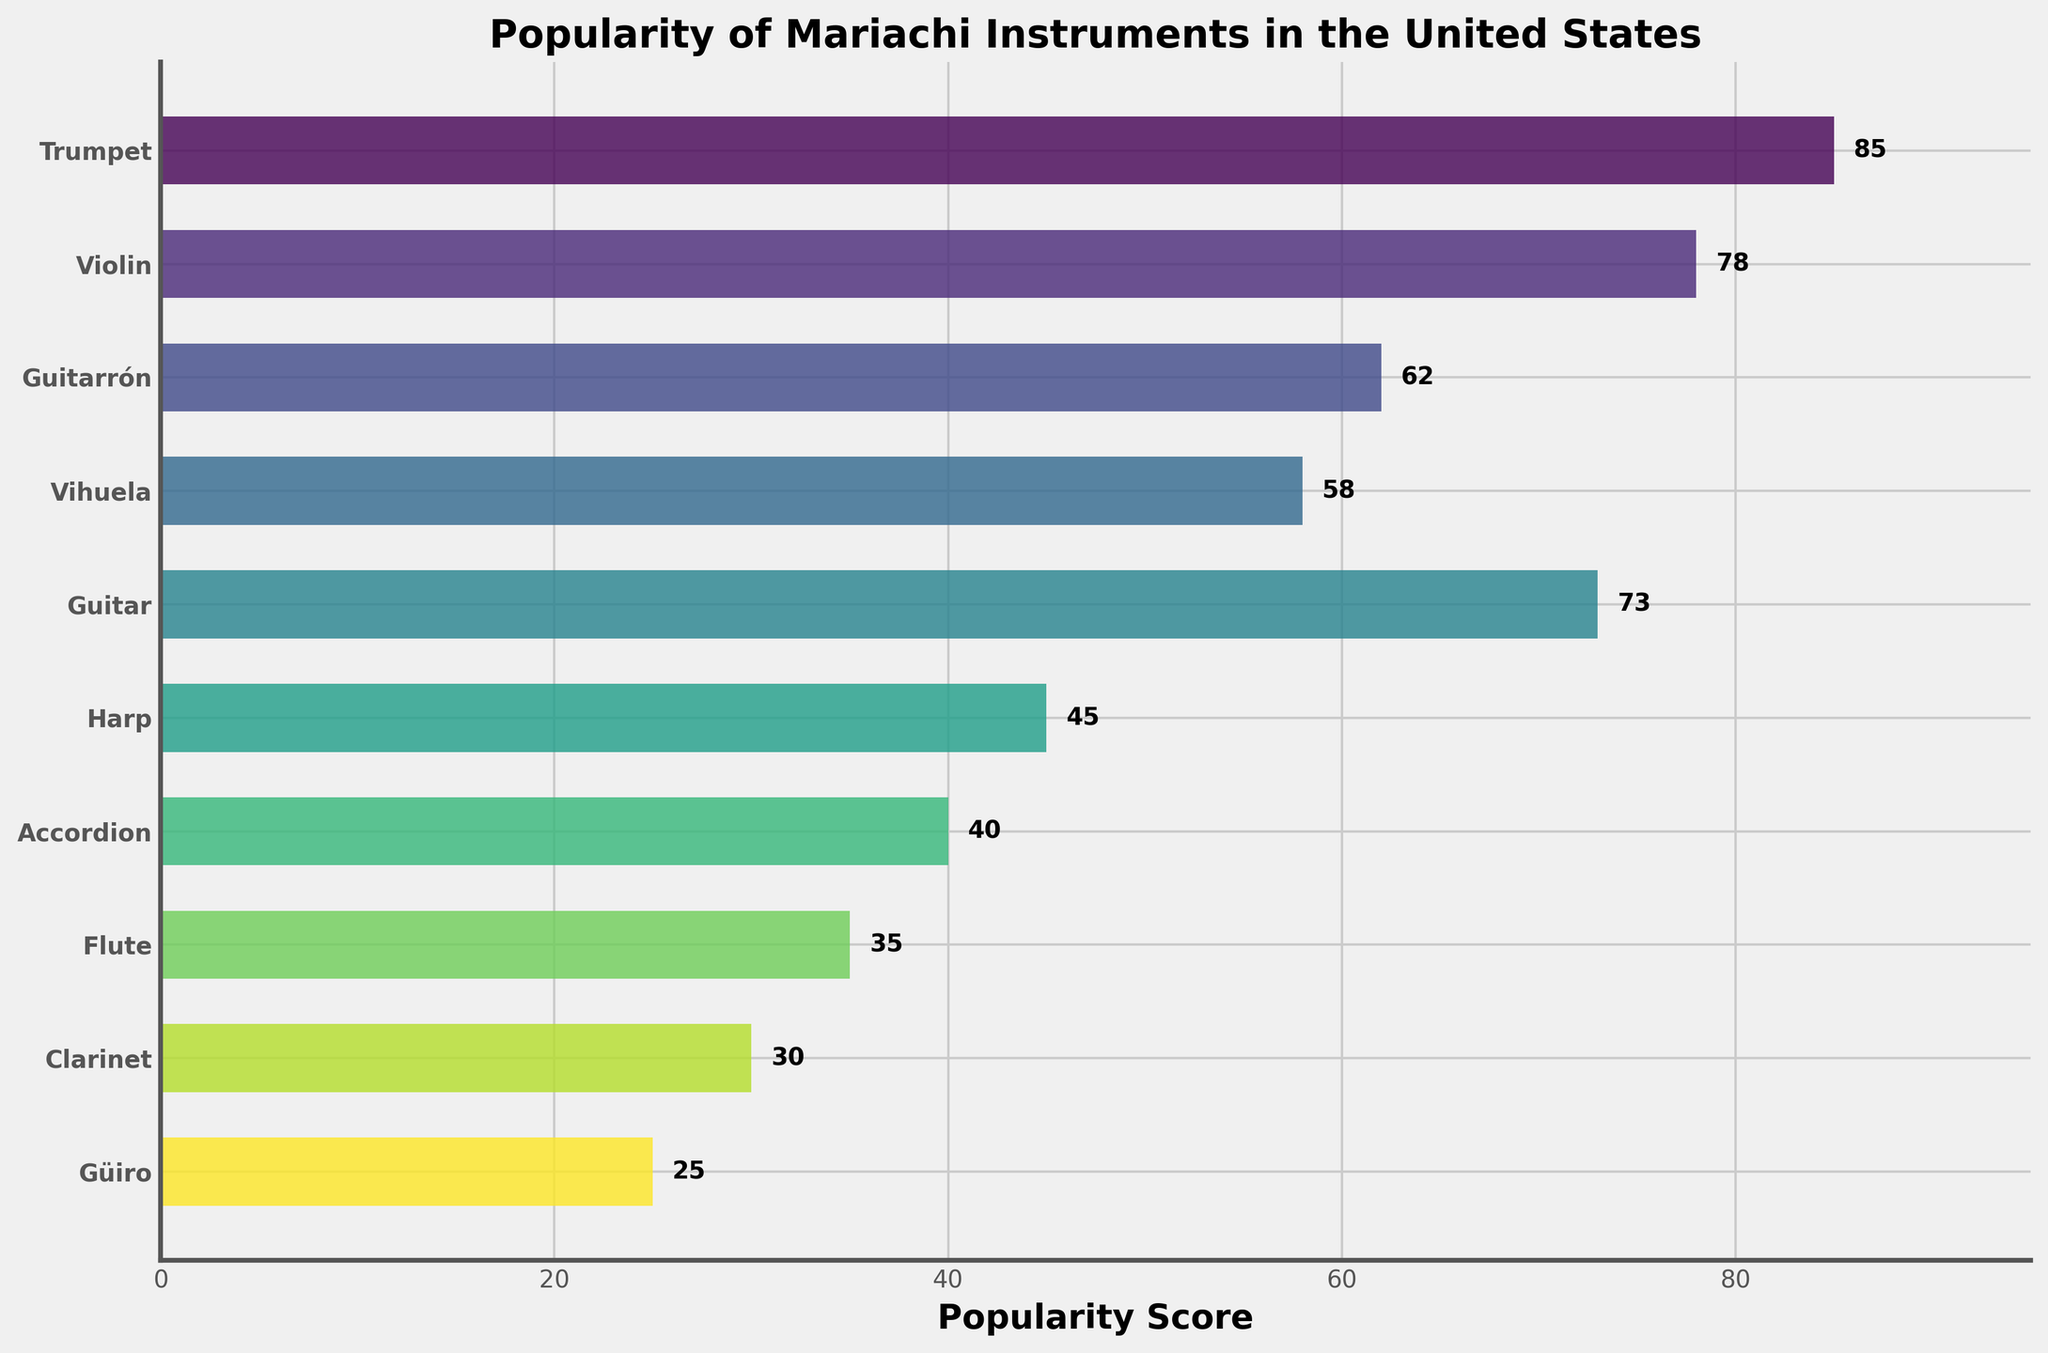Which instrument has the highest popularity score? The instrument with the highest popularity score can be identified by looking at the bar that extends the farthest to the right.
Answer: Trumpet What is the popularity score of the Guitarrón? Locate the bar corresponding to the Guitarrón by checking the y-axis labels and reading its length value.
Answer: 62 How many instruments have a popularity score greater than 50? Count the bars that extend beyond the 50 mark on the x-axis.
Answer: 5 Which instrument has the lowest popularity score? Find the shortest bar in the plot, which corresponds to the least popular instrument.
Answer: Güiro How much more popular is the Trumpet compared to the Flute? Subtract the popularity score of the Flute from that of the Trumpet (85 - 35).
Answer: 50 What is the median popularity score of all the instruments? Arrange the popularity scores in ascending order and find the middle value. The sorted scores are 25, 30, 35, 40, 45, 58, 62, 73, 78, and 85; the median is the average of the 5th and 6th values ((45 + 58) / 2).
Answer: 51.5 Do the Trumpet and Violin combined have more than 150 points in popularity? Add the popularity scores of the Trumpet and Violin (85 + 78) and check if the sum is greater than 150.
Answer: Yes Which instruments have popularity scores between 30 and 60? Identify and list the instruments whose bars fall between the 30 and 60 marks on the x-axis.
Answer: Vihuela, Guitarrón, Harp, Accordion, Flute, Clarinet How many instruments have a popularity score less than that of the Violin? Count the bars shorter than the one corresponding to the Violin.
Answer: 8 What is the total popularity score of all the instruments? Sum up the popularity scores of all the instruments (85 + 78 + 62 + 58 + 73 + 45 + 40 + 35 + 30 + 25).
Answer: 531 Which two instruments have the smallest difference in popularity scores? Calculate the differences between each pair of instruments' scores and identify the pair with the smallest difference. Compare nearest values: 85-78=7, 78-73=5, 73-62=11, 62-58=4, 58-45=13, 45-40=5, 40-35=5, 35-30=5, 30-25=5; the smallest difference is between the Vihuela and Guitarrón (62 - 58).
Answer: Vihuela and Guitarrón 